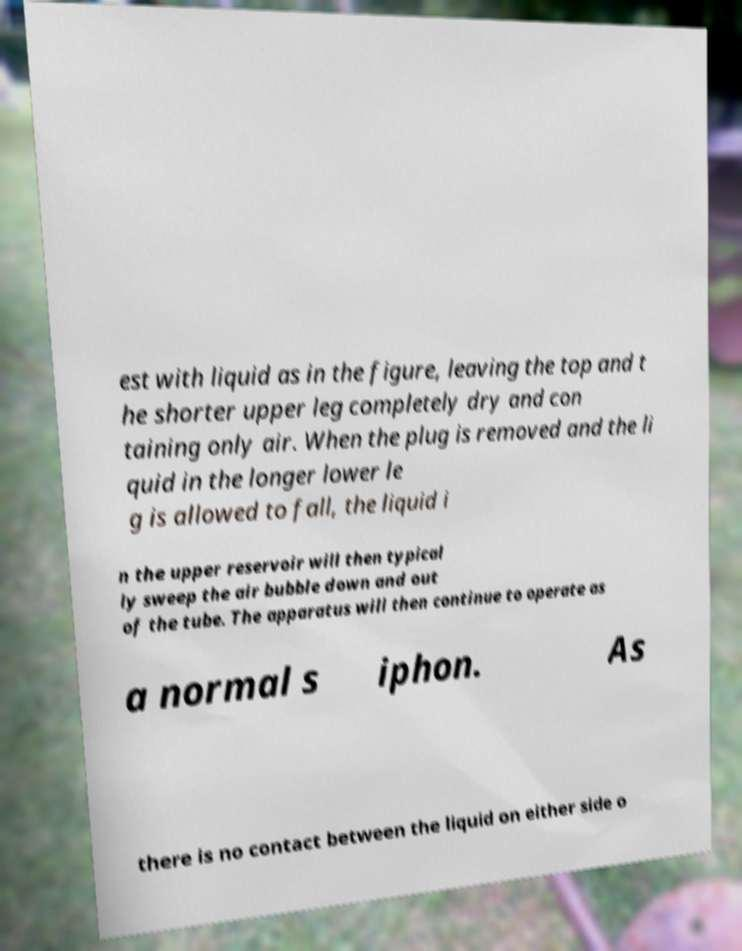There's text embedded in this image that I need extracted. Can you transcribe it verbatim? est with liquid as in the figure, leaving the top and t he shorter upper leg completely dry and con taining only air. When the plug is removed and the li quid in the longer lower le g is allowed to fall, the liquid i n the upper reservoir will then typical ly sweep the air bubble down and out of the tube. The apparatus will then continue to operate as a normal s iphon. As there is no contact between the liquid on either side o 